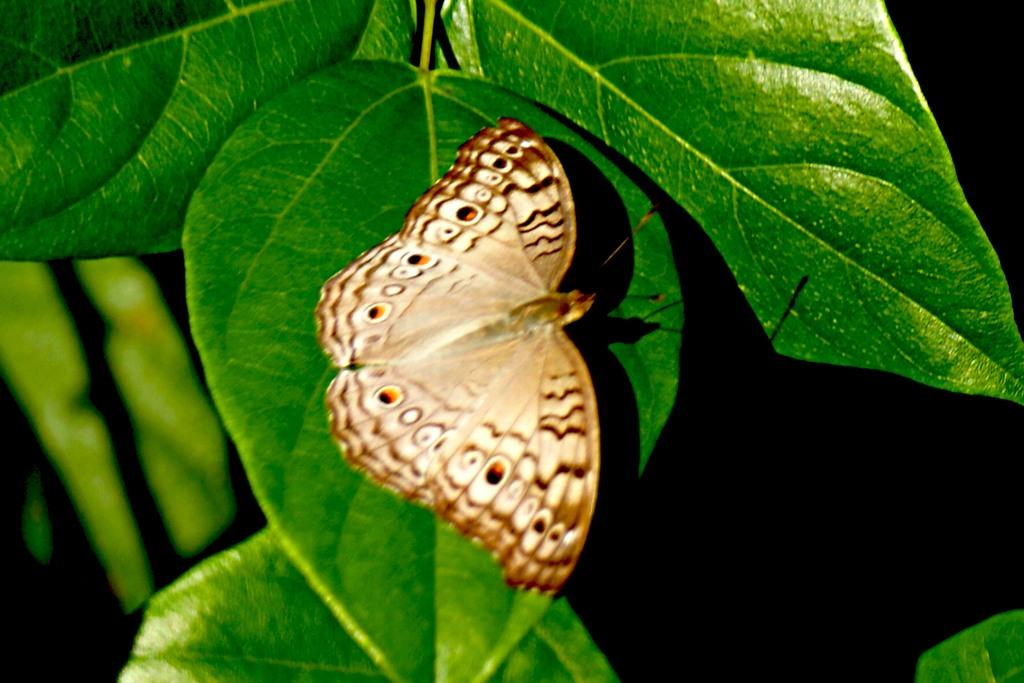What type of vegetation is visible in the image? There are leaves in the image. What type of insect can be seen in the image? There is a butterfly in the image. What is the color of the background in the image? The background of the image is dark. Can you tell me what type of watch is being worn by the beetle in the image? There is no beetle or watch present in the image. What type of picture is being displayed on the wall in the image? There is no picture or wall present in the image. 